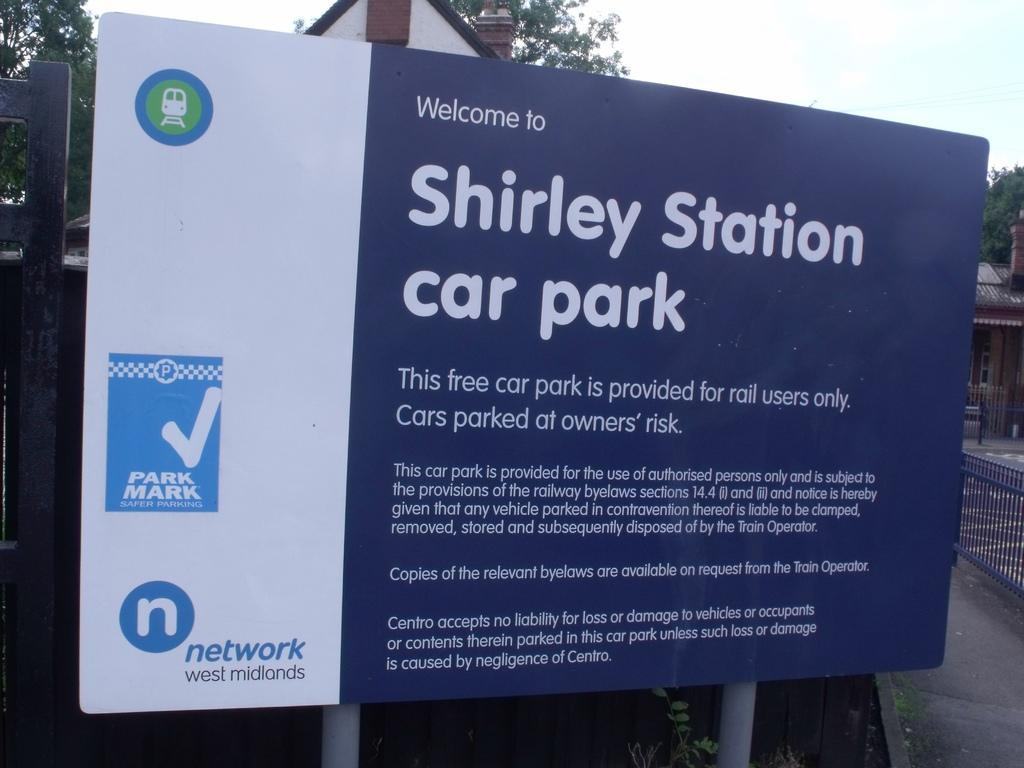<image>
Provide a brief description of the given image. A welcome board for Shirley Station car park. 